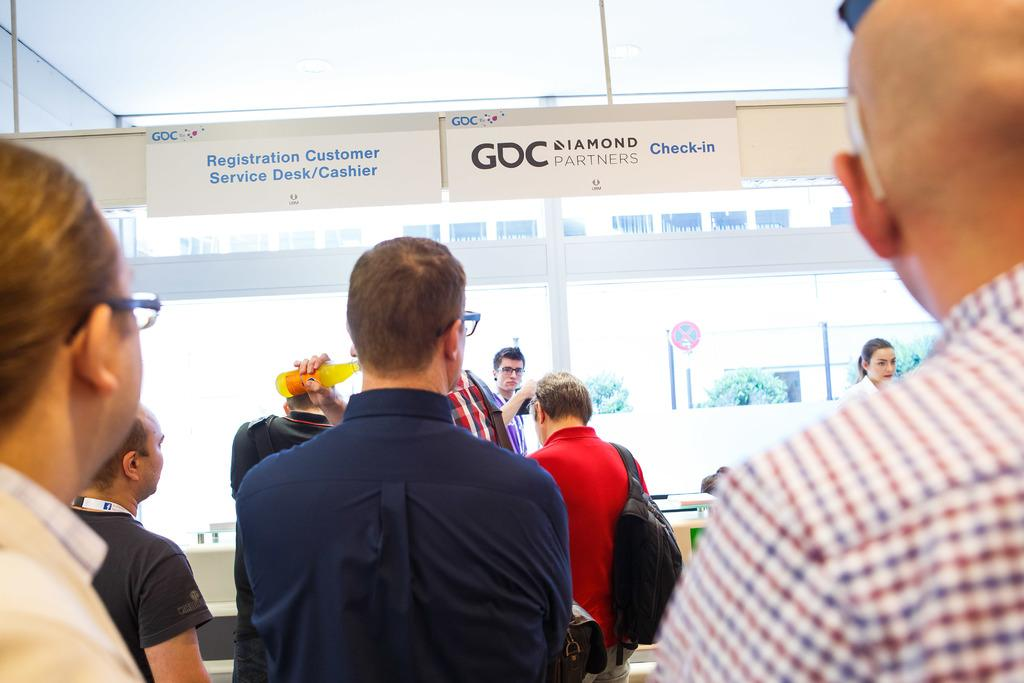How many people are present in the image? There are people in the image, but the exact number is not specified. What type of objects can be seen in the image? There are boards, a signboard, poles, trees, and other objects in the image. What are some people doing in the image? Some people are wearing bags, and one person is holding a bottle. What type of joke is being told by the person holding the bean in the image? There is no person holding a bean in the image, and therefore no joke can be observed. 